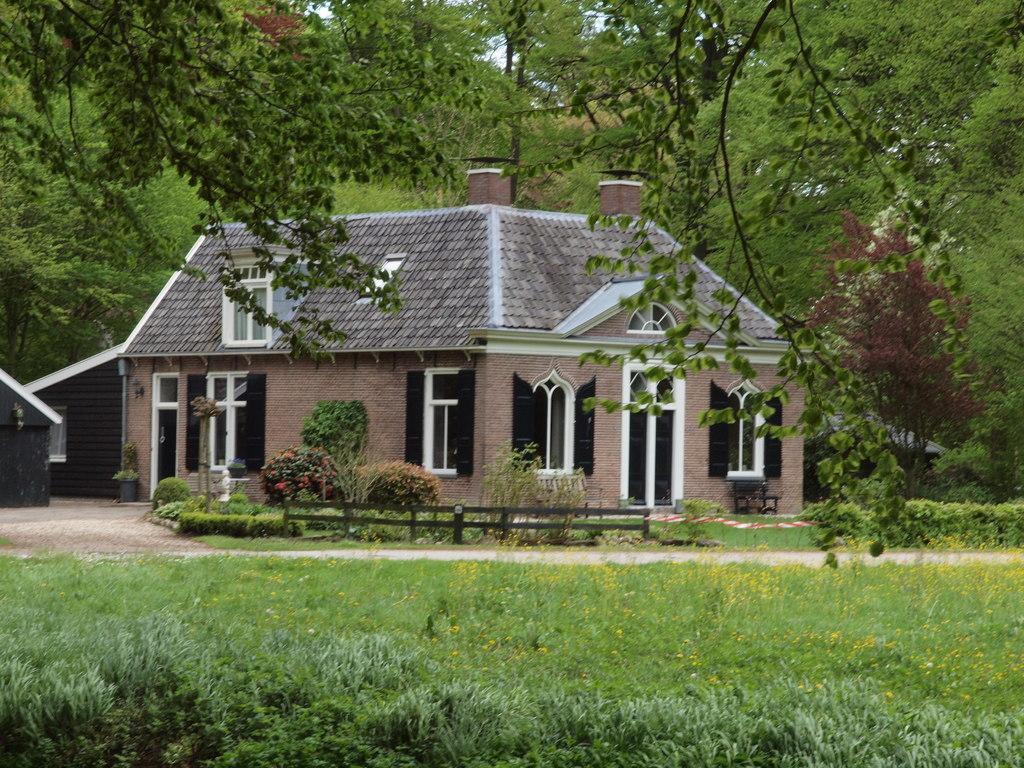How would you summarize this image in a sentence or two? In this image we can see a house. On the house we can see windows and doors. In front of the house we can see wooden fence, plants, flowers and the grass. Behind the house we can see a group of trees. At the top we can see the trees and the sky. 